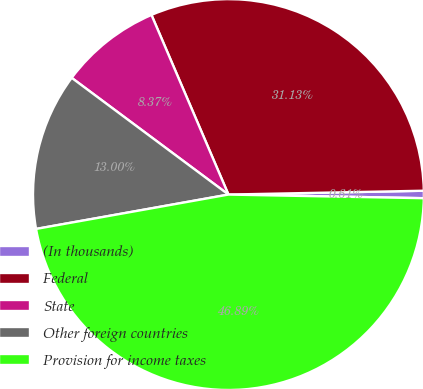Convert chart to OTSL. <chart><loc_0><loc_0><loc_500><loc_500><pie_chart><fcel>(In thousands)<fcel>Federal<fcel>State<fcel>Other foreign countries<fcel>Provision for income taxes<nl><fcel>0.61%<fcel>31.13%<fcel>8.37%<fcel>13.0%<fcel>46.89%<nl></chart> 